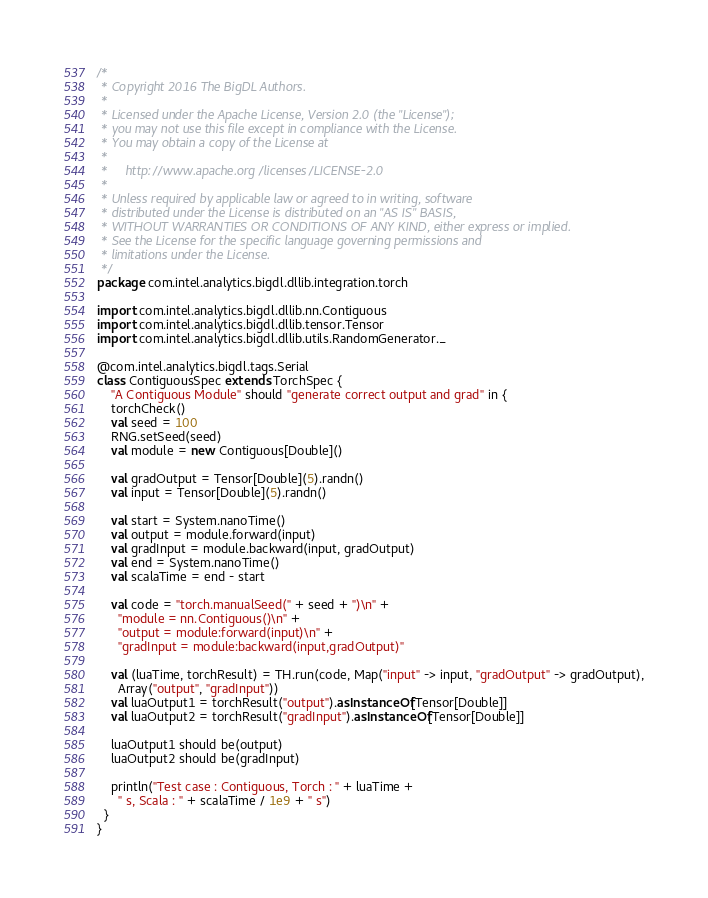Convert code to text. <code><loc_0><loc_0><loc_500><loc_500><_Scala_>/*
 * Copyright 2016 The BigDL Authors.
 *
 * Licensed under the Apache License, Version 2.0 (the "License");
 * you may not use this file except in compliance with the License.
 * You may obtain a copy of the License at
 *
 *     http://www.apache.org/licenses/LICENSE-2.0
 *
 * Unless required by applicable law or agreed to in writing, software
 * distributed under the License is distributed on an "AS IS" BASIS,
 * WITHOUT WARRANTIES OR CONDITIONS OF ANY KIND, either express or implied.
 * See the License for the specific language governing permissions and
 * limitations under the License.
 */
package com.intel.analytics.bigdl.dllib.integration.torch

import com.intel.analytics.bigdl.dllib.nn.Contiguous
import com.intel.analytics.bigdl.dllib.tensor.Tensor
import com.intel.analytics.bigdl.dllib.utils.RandomGenerator._

@com.intel.analytics.bigdl.tags.Serial
class ContiguousSpec extends TorchSpec {
    "A Contiguous Module" should "generate correct output and grad" in {
    torchCheck()
    val seed = 100
    RNG.setSeed(seed)
    val module = new Contiguous[Double]()

    val gradOutput = Tensor[Double](5).randn()
    val input = Tensor[Double](5).randn()

    val start = System.nanoTime()
    val output = module.forward(input)
    val gradInput = module.backward(input, gradOutput)
    val end = System.nanoTime()
    val scalaTime = end - start

    val code = "torch.manualSeed(" + seed + ")\n" +
      "module = nn.Contiguous()\n" +
      "output = module:forward(input)\n" +
      "gradInput = module:backward(input,gradOutput)"

    val (luaTime, torchResult) = TH.run(code, Map("input" -> input, "gradOutput" -> gradOutput),
      Array("output", "gradInput"))
    val luaOutput1 = torchResult("output").asInstanceOf[Tensor[Double]]
    val luaOutput2 = torchResult("gradInput").asInstanceOf[Tensor[Double]]

    luaOutput1 should be(output)
    luaOutput2 should be(gradInput)

    println("Test case : Contiguous, Torch : " + luaTime +
      " s, Scala : " + scalaTime / 1e9 + " s")
  }
}
</code> 